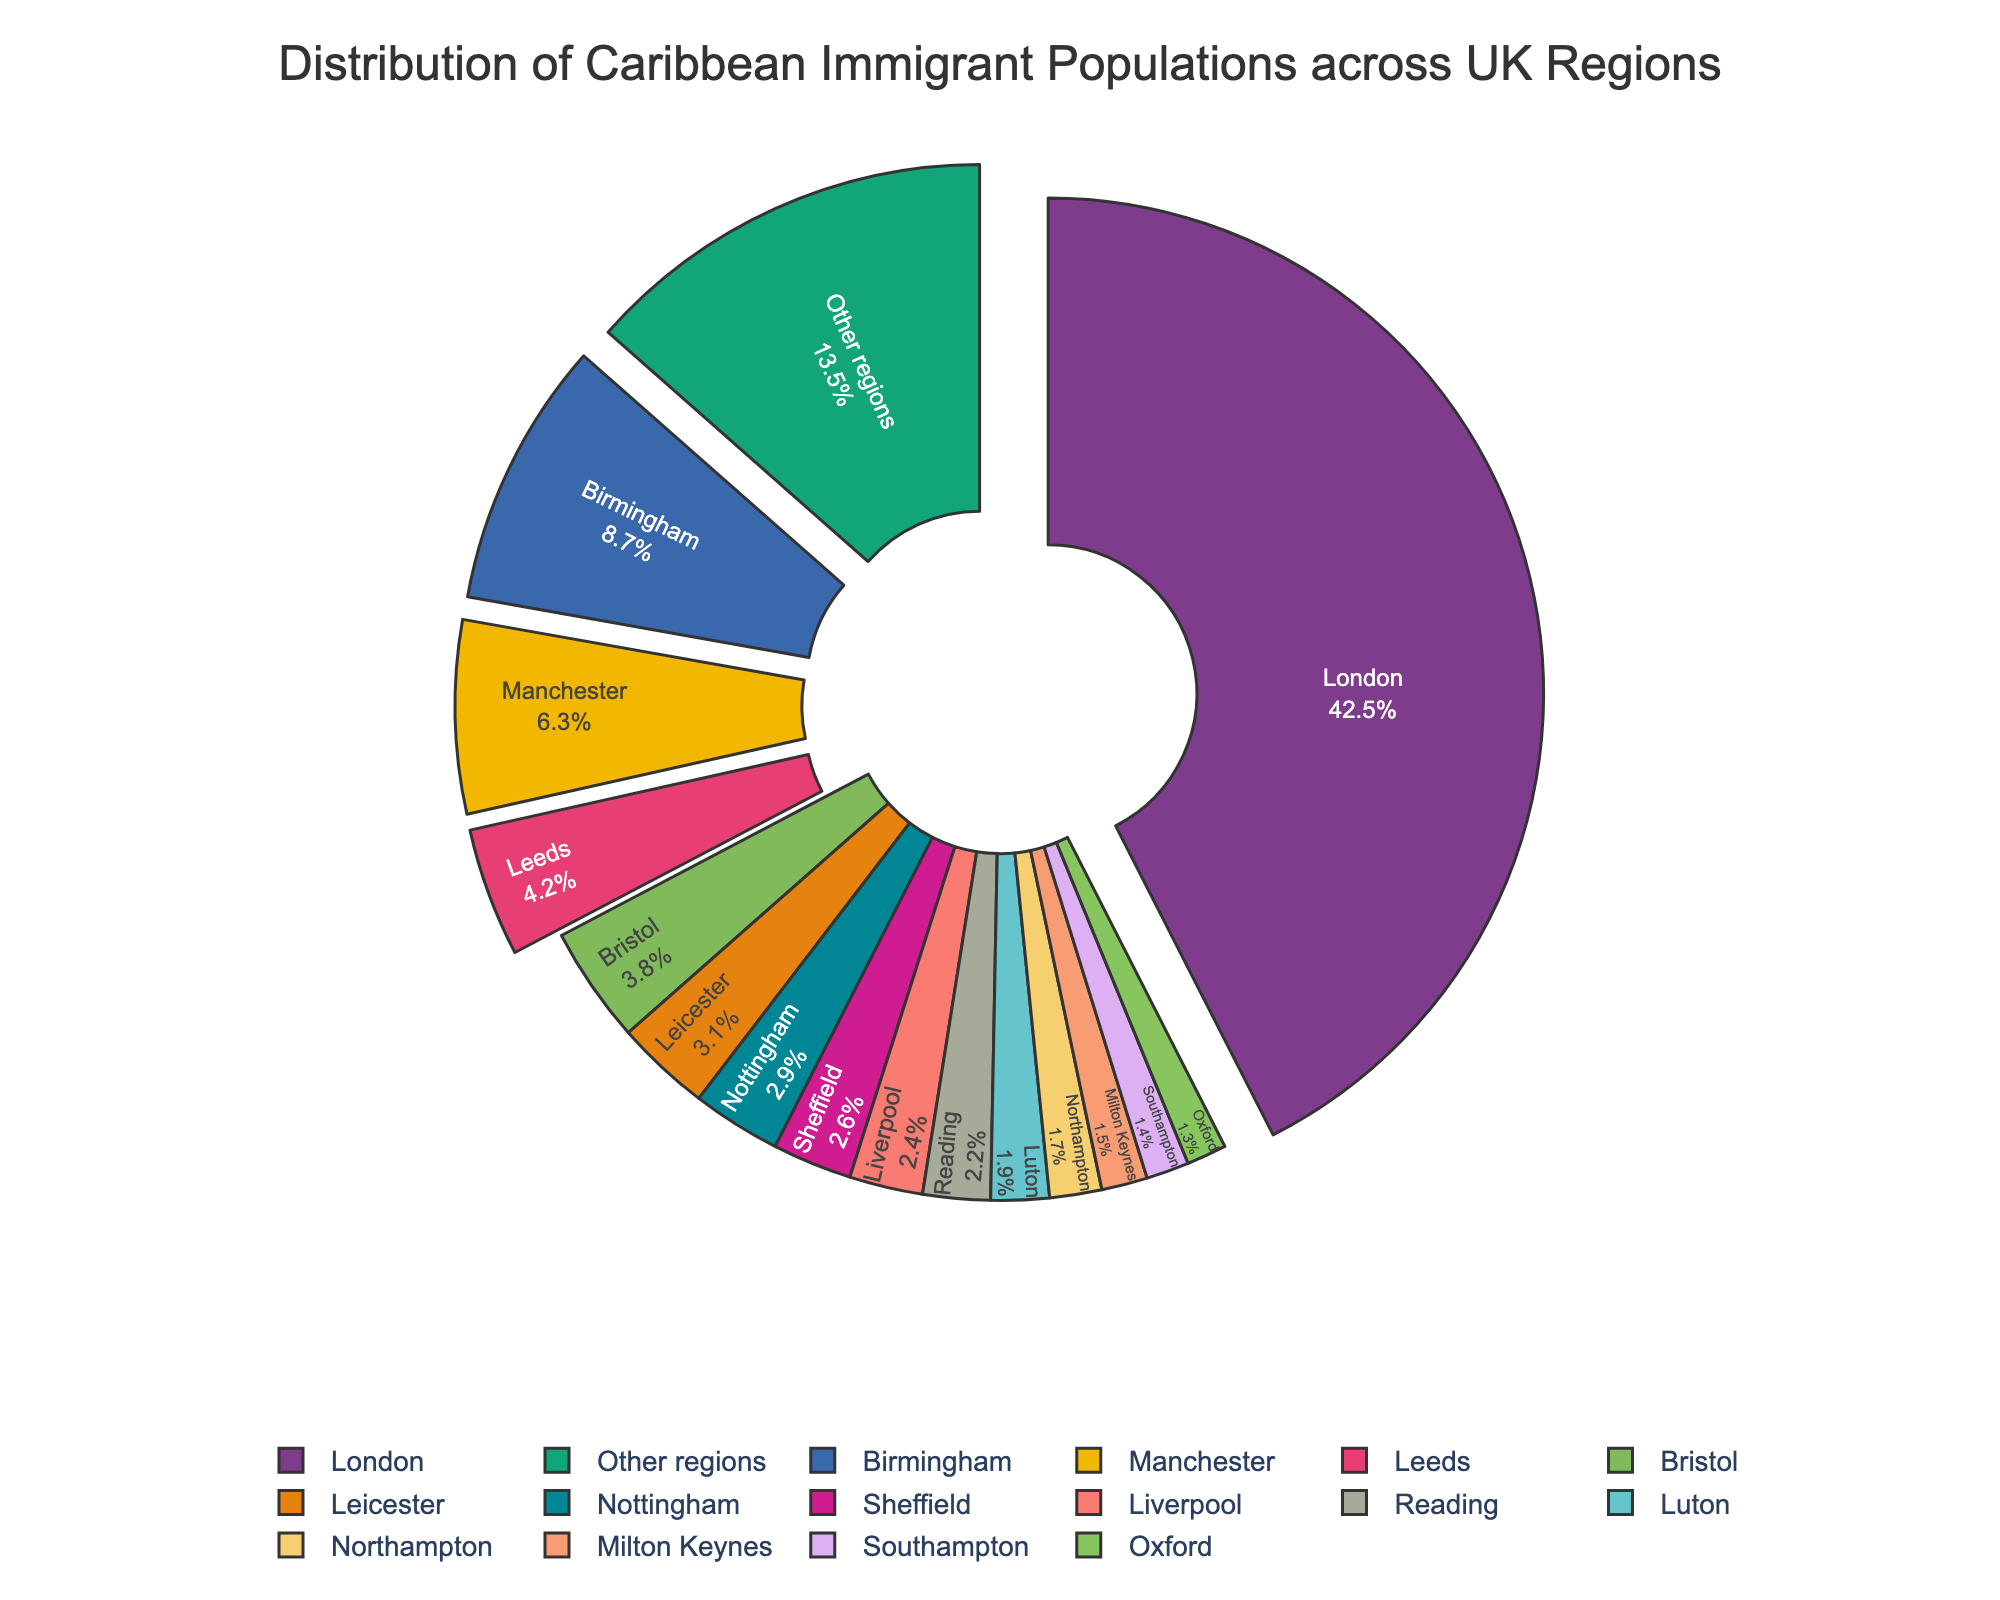Which region has the highest percentage of Caribbean immigrant populations? Observe the figure and identify the region with the largest slice. The largest slice is marked as "London" with 42.5%.
Answer: London What percentage of Caribbean immigrants live in Birmingham? Look at the pie chart and find the slice labeled "Birmingham". It shows 8.7%.
Answer: 8.7% How many regions have a percentage higher than 5%? Count the number of slices with percentages greater than 5%. London (42.5%), Birmingham (8.7%), and Manchester (6.3%) are the regions.
Answer: 3 What's the total percentage of Caribbean immigrants living in Leeds and Bristol combined? Add the percentages of Leeds (4.2%) and Bristol (3.8%). Thus, 4.2 + 3.8 = 8%.
Answer: 8% Compare the percentage of Caribbean immigrants in Leicester to that in Nottingham. Which is higher? Refer to the figure and compare the slices labeled "Leicester" (3.1%) with "Nottingham" (2.9%). Leicester is higher.
Answer: Leicester What is the total percentage of Caribbean immigrants in the regions with shares below 2%? Sum the percentages of Luton, Northampton, Milton Keynes, Southampton, Oxford, and Other regions below 2%: 1.9 + 1.7 + 1.5 + 1.4 + 1.3 = 7.8%.
Answer: 7.8% Which region has a larger Caribbean immigrant population: Liverpool or Reading? By examining the slices, Liverpool has 2.4% and Reading has 2.2%. Liverpool is larger.
Answer: Liverpool What is the combined percentage of Caribbean immigrants in the top five regions? Sum the percentages of the top five regions: London (42.5%), Birmingham (8.7%), Manchester (6.3%), Leeds (4.2%), and Bristol (3.8%). Thus, 42.5 + 8.7 + 6.3 + 4.2 + 3.8 = 65.5%.
Answer: 65.5% Is the percentage of Caribbean immigrants in Manchester closer to that in Birmingham or Leeds? Check the slices and compare Manchester (6.3%) to Birmingham (8.7%) and Leeds (4.2%). The difference from Manchester to Birmingham is 8.7 - 6.3 = 2.4, and the difference from Manchester to Leeds is 6.3 - 4.2 = 2.1. Thus, Manchester is closer to Leeds.
Answer: Leeds 